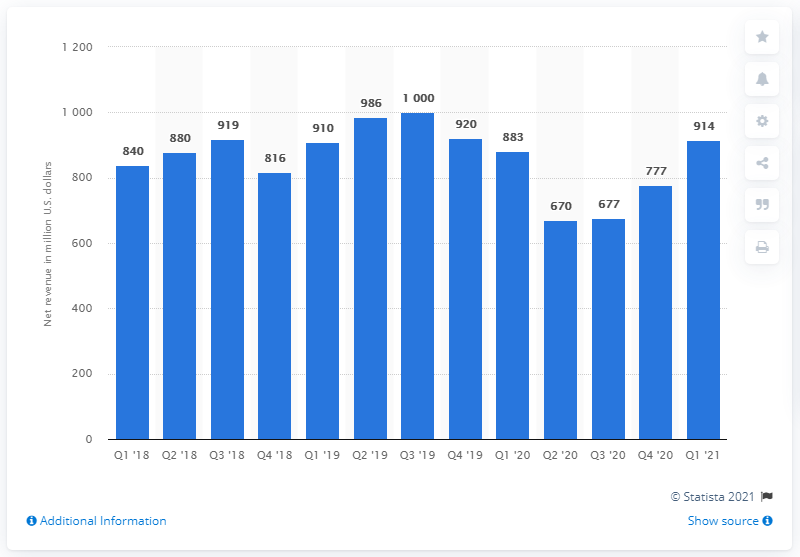Mention a couple of crucial points in this snapshot. In the first quarter of 2021, Intel's Internet of Things Group generated revenue amounting to $914 million. Intel's Internet of Things Group (IOTG) revenue for the third quarter of 2019 was $914 million. 